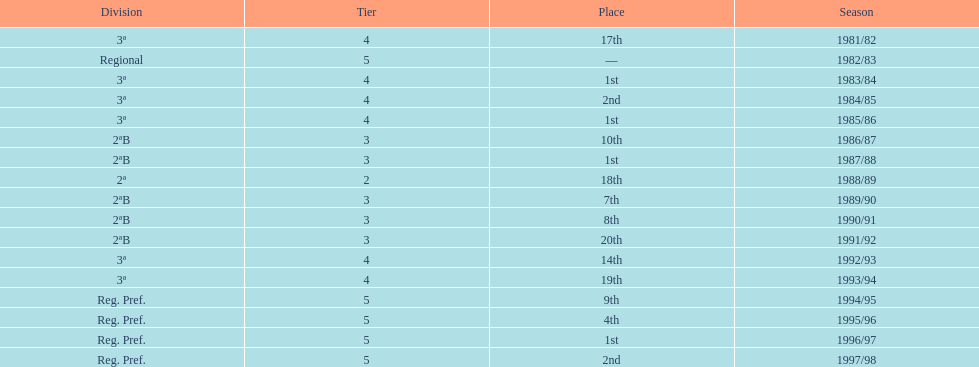What year has no place indicated? 1982/83. 